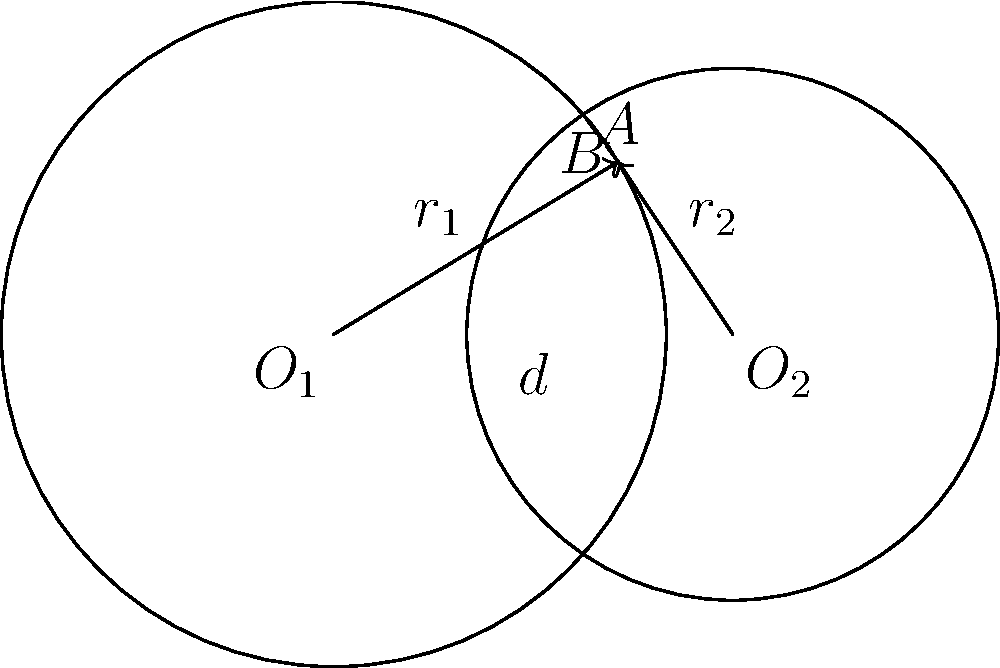In your latest writing project, you're exploring the intersection of mathematics and storytelling. You come across a problem involving two intersecting circles that reminds you of a professor's lecture. Given two circles with centers $O_1$ and $O_2$, radii $r_1 = 5$ and $r_2 = 4$ respectively, and the distance between their centers $d = 6$, calculate the length of their common chord AB. Let's approach this step-by-step:

1) First, recall the formula for the length of a common chord (let's call it $2c$) when two circles intersect:

   $$2c = \frac{2}{\d}\sqrt{(-d+r_1+r_2)(d+r_1-r_2)(d-r_1+r_2)(d+r_1+r_2)}$$

2) We're given:
   $r_1 = 5$, $r_2 = 4$, $d = 6$

3) Let's substitute these values into the formula:

   $$2c = \frac{2}{6}\sqrt{(-6+5+4)(6+5-4)(6-5+4)(6+5+4)}$$

4) Simplify inside the square root:

   $$2c = \frac{1}{3}\sqrt{(3)(7)(5)(15)}$$

5) Multiply the numbers inside the square root:

   $$2c = \frac{1}{3}\sqrt{1575}$$

6) Simplify:

   $$2c = \frac{\sqrt{1575}}{3}$$

7) The question asks for the length of AB, which is $2c$. So this is our final answer.
Answer: $\frac{\sqrt{1575}}{3}$ 